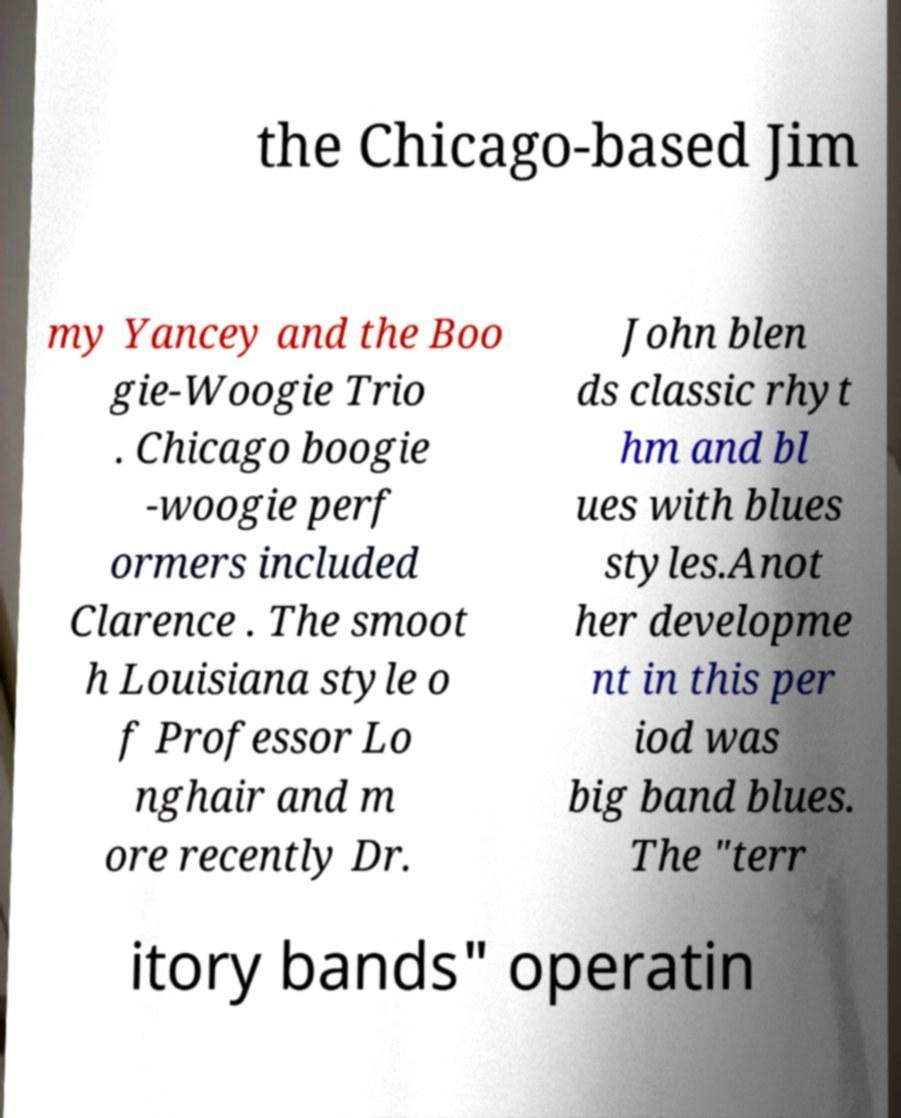Please read and relay the text visible in this image. What does it say? the Chicago-based Jim my Yancey and the Boo gie-Woogie Trio . Chicago boogie -woogie perf ormers included Clarence . The smoot h Louisiana style o f Professor Lo nghair and m ore recently Dr. John blen ds classic rhyt hm and bl ues with blues styles.Anot her developme nt in this per iod was big band blues. The "terr itory bands" operatin 